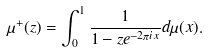<formula> <loc_0><loc_0><loc_500><loc_500>\mu ^ { + } ( z ) = \int _ { 0 } ^ { 1 } \frac { 1 } { 1 - z e ^ { - 2 \pi i x } } d \mu ( x ) .</formula> 